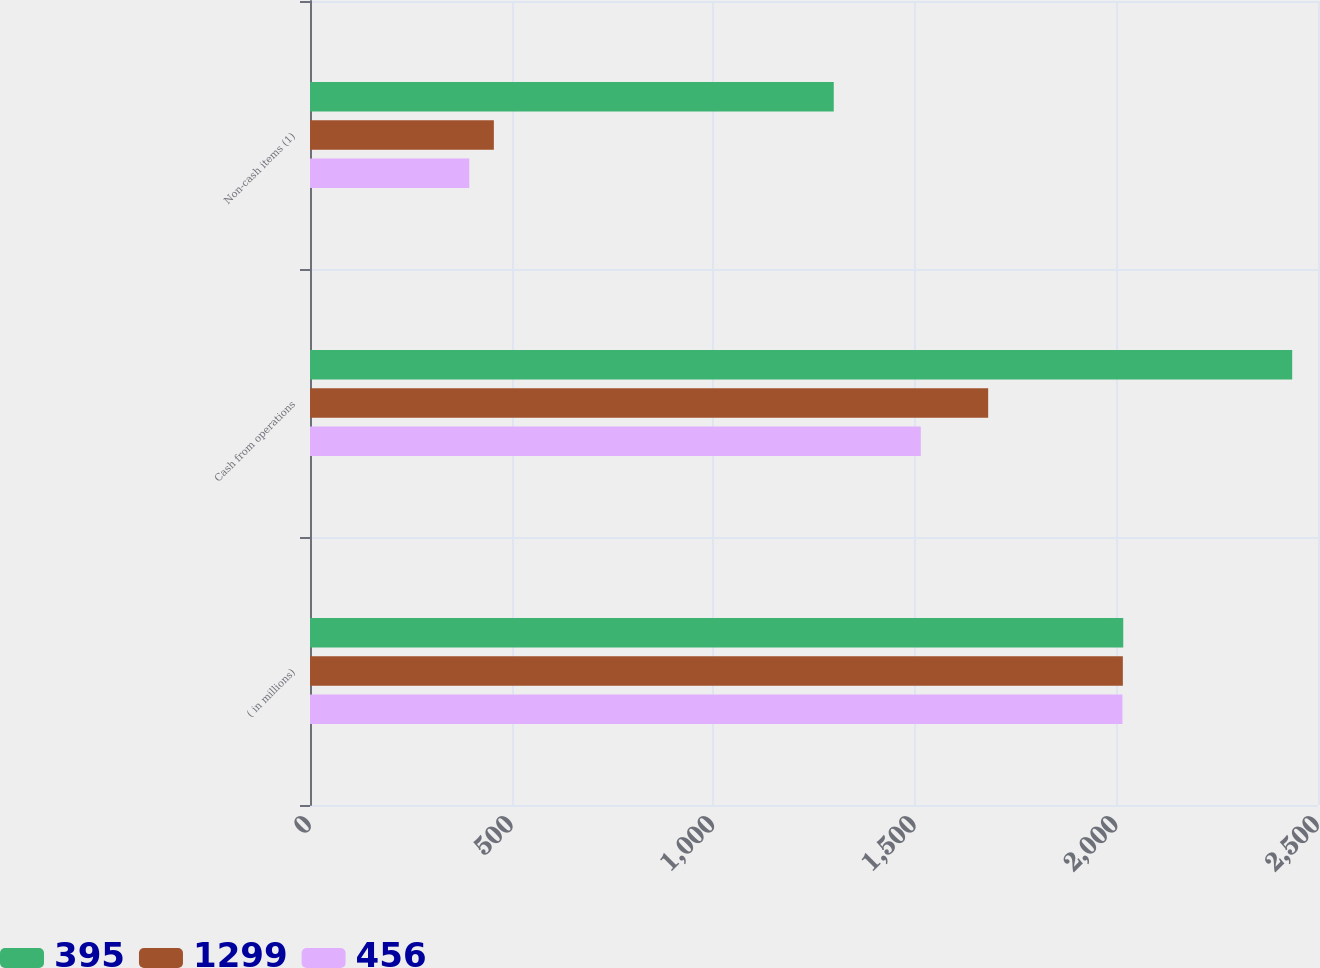<chart> <loc_0><loc_0><loc_500><loc_500><stacked_bar_chart><ecel><fcel>( in millions)<fcel>Cash from operations<fcel>Non-cash items (1)<nl><fcel>395<fcel>2017<fcel>2436<fcel>1299<nl><fcel>1299<fcel>2016<fcel>1682<fcel>456<nl><fcel>456<fcel>2015<fcel>1515<fcel>395<nl></chart> 